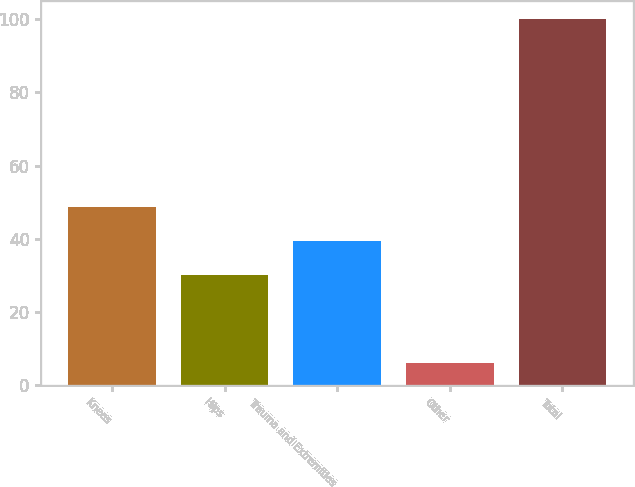Convert chart to OTSL. <chart><loc_0><loc_0><loc_500><loc_500><bar_chart><fcel>Knees<fcel>Hips<fcel>Trauma and Extremities<fcel>Other<fcel>Total<nl><fcel>48.8<fcel>30<fcel>39.4<fcel>6<fcel>100<nl></chart> 